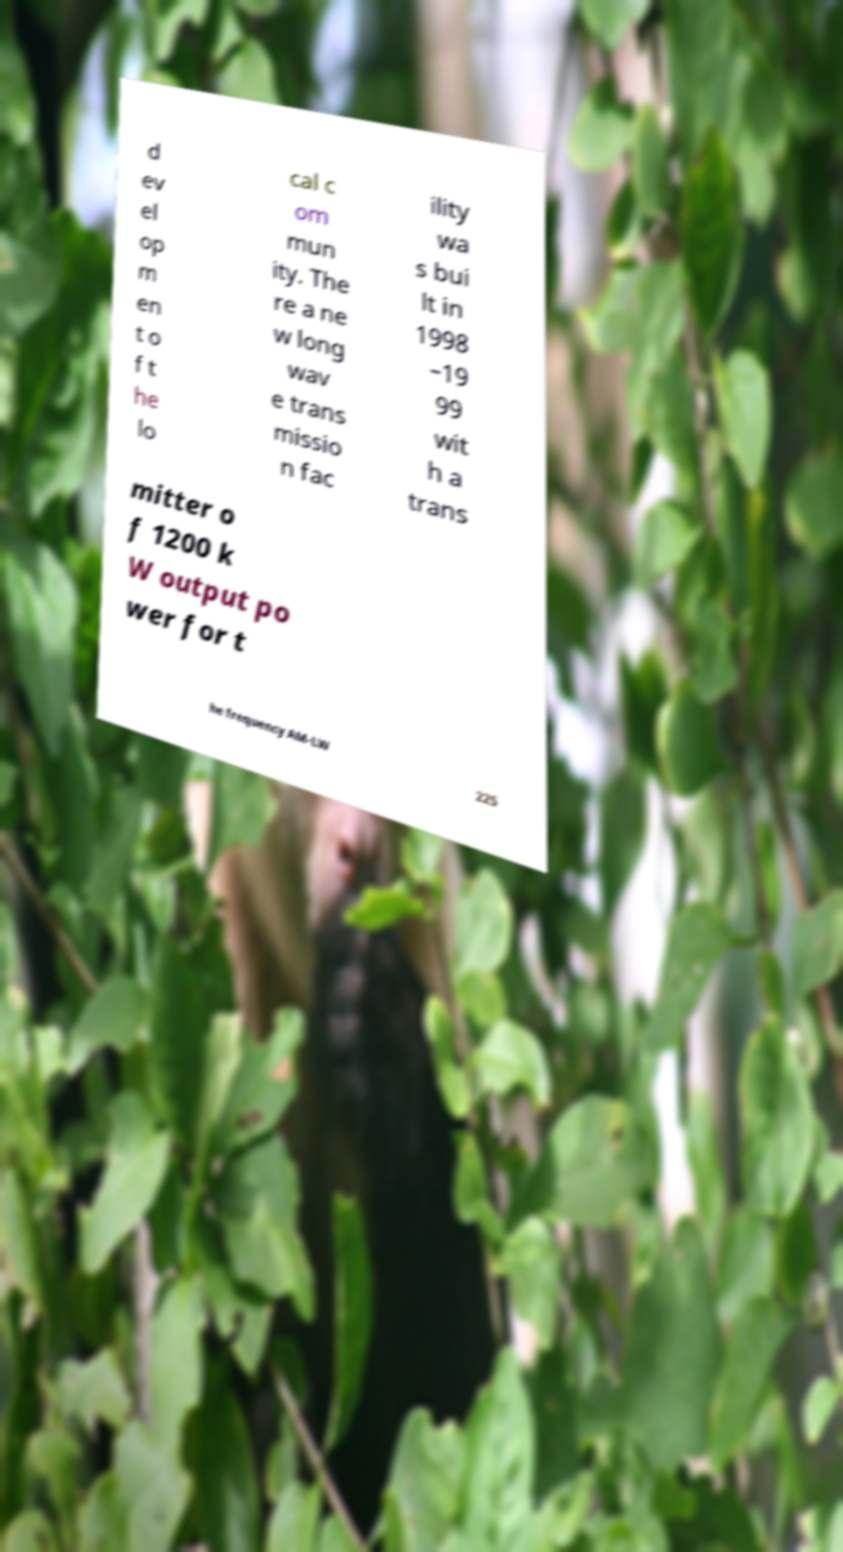For documentation purposes, I need the text within this image transcribed. Could you provide that? d ev el op m en t o f t he lo cal c om mun ity. The re a ne w long wav e trans missio n fac ility wa s bui lt in 1998 –19 99 wit h a trans mitter o f 1200 k W output po wer for t he frequency AM-LW 225 